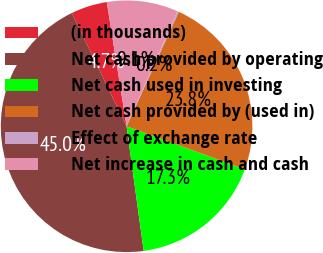Convert chart to OTSL. <chart><loc_0><loc_0><loc_500><loc_500><pie_chart><fcel>(in thousands)<fcel>Net cash provided by operating<fcel>Net cash used in investing<fcel>Net cash provided by (used in)<fcel>Effect of exchange rate<fcel>Net increase in cash and cash<nl><fcel>4.66%<fcel>44.99%<fcel>17.28%<fcel>23.75%<fcel>0.18%<fcel>9.14%<nl></chart> 